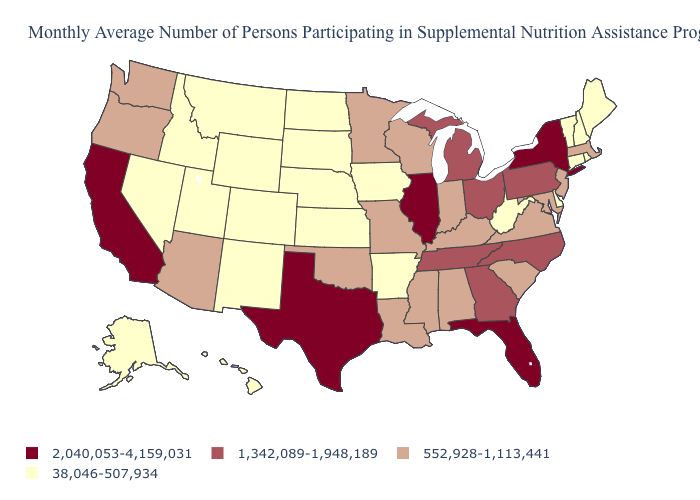What is the lowest value in the USA?
Answer briefly. 38,046-507,934. What is the value of Alaska?
Write a very short answer. 38,046-507,934. What is the highest value in the USA?
Keep it brief. 2,040,053-4,159,031. Does the map have missing data?
Answer briefly. No. Is the legend a continuous bar?
Keep it brief. No. Name the states that have a value in the range 2,040,053-4,159,031?
Write a very short answer. California, Florida, Illinois, New York, Texas. Which states have the lowest value in the USA?
Give a very brief answer. Alaska, Arkansas, Colorado, Connecticut, Delaware, Hawaii, Idaho, Iowa, Kansas, Maine, Montana, Nebraska, Nevada, New Hampshire, New Mexico, North Dakota, Rhode Island, South Dakota, Utah, Vermont, West Virginia, Wyoming. What is the highest value in the West ?
Write a very short answer. 2,040,053-4,159,031. Among the states that border Oregon , which have the highest value?
Write a very short answer. California. Does the map have missing data?
Write a very short answer. No. What is the highest value in the West ?
Keep it brief. 2,040,053-4,159,031. Does Nebraska have the lowest value in the MidWest?
Concise answer only. Yes. Name the states that have a value in the range 1,342,089-1,948,189?
Concise answer only. Georgia, Michigan, North Carolina, Ohio, Pennsylvania, Tennessee. Name the states that have a value in the range 38,046-507,934?
Quick response, please. Alaska, Arkansas, Colorado, Connecticut, Delaware, Hawaii, Idaho, Iowa, Kansas, Maine, Montana, Nebraska, Nevada, New Hampshire, New Mexico, North Dakota, Rhode Island, South Dakota, Utah, Vermont, West Virginia, Wyoming. Name the states that have a value in the range 1,342,089-1,948,189?
Concise answer only. Georgia, Michigan, North Carolina, Ohio, Pennsylvania, Tennessee. 